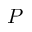<formula> <loc_0><loc_0><loc_500><loc_500>P</formula> 